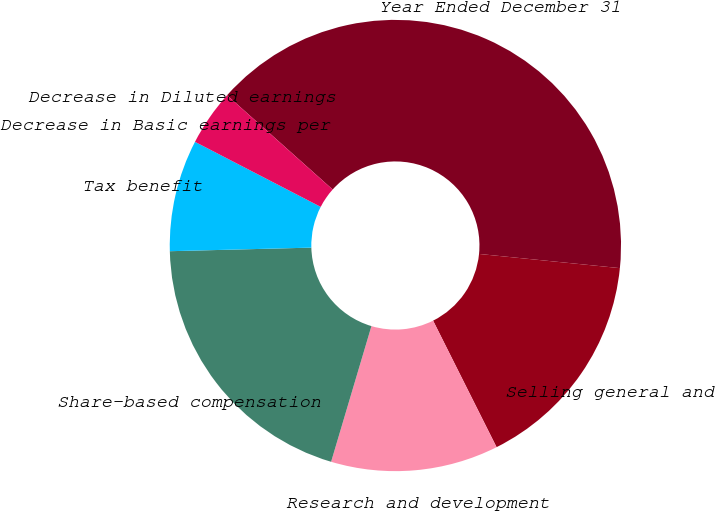Convert chart. <chart><loc_0><loc_0><loc_500><loc_500><pie_chart><fcel>Year Ended December 31<fcel>Selling general and<fcel>Research and development<fcel>Share-based compensation<fcel>Tax benefit<fcel>Decrease in Basic earnings per<fcel>Decrease in Diluted earnings<nl><fcel>40.0%<fcel>16.0%<fcel>12.0%<fcel>20.0%<fcel>8.0%<fcel>0.0%<fcel>4.0%<nl></chart> 